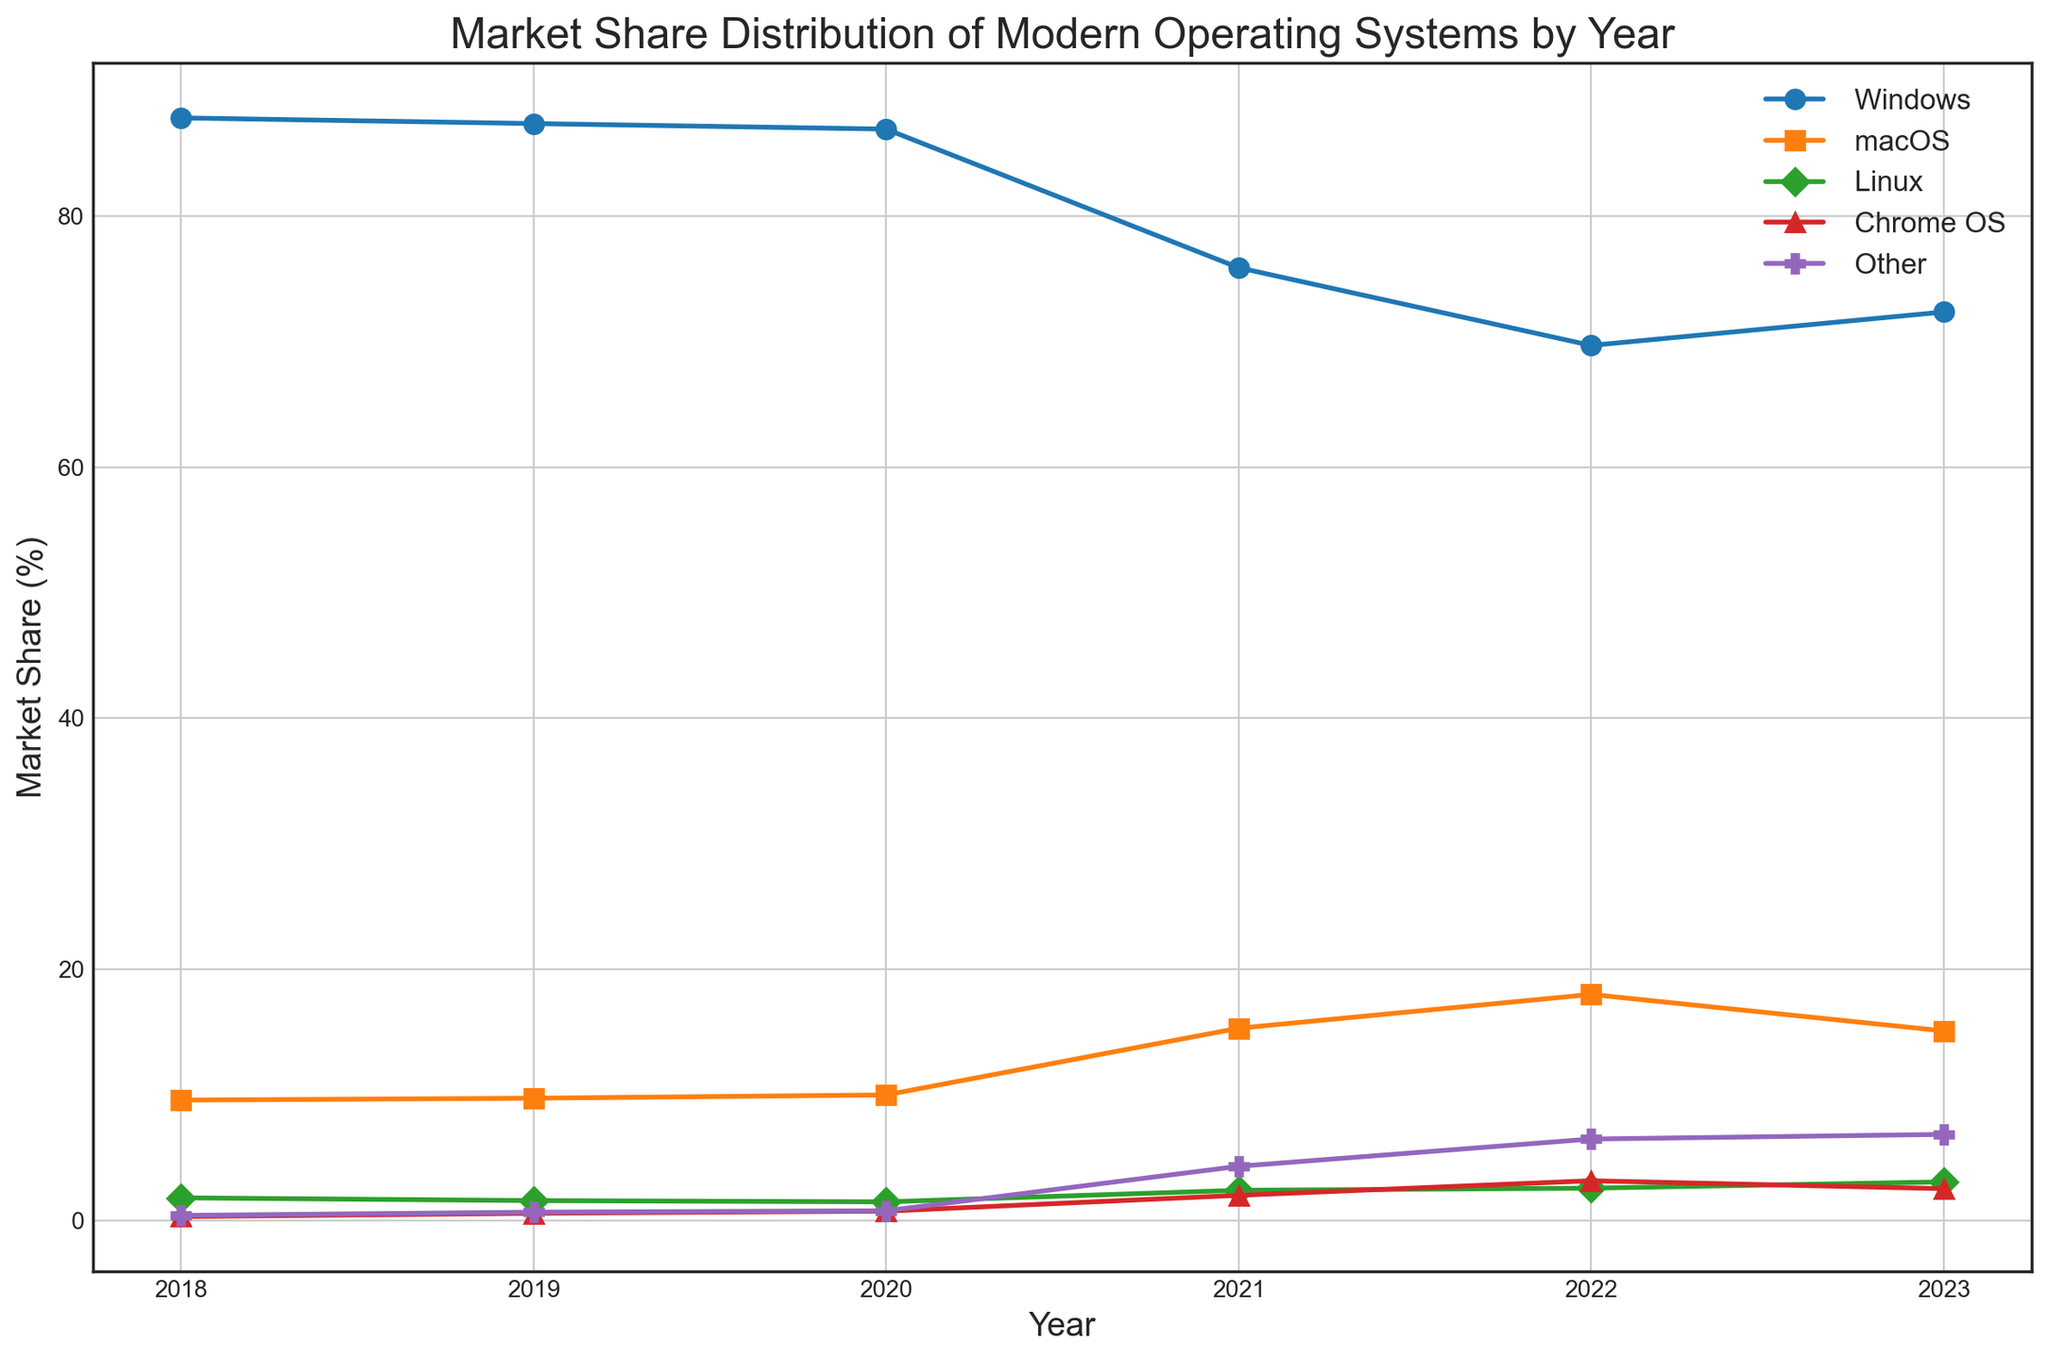What is the trend of the market share of Windows from 2018 to 2023? To find the trend, look at the values of Windows from 2018 to 2023: 87.79, 87.34, 86.9, 75.87, 69.68, 72.34. Notice that there is a general decrease from 2018 to 2022, but a slight increase in 2023.
Answer: Generally decreasing with a slight rise in 2023 Which year has the highest market share for macOS? To determine this, compare the market share values of macOS for each year. The values are 9.61, 9.76, 10.02, 15.33, 18.02, and 15.12. The highest value is 18.02 in 2022.
Answer: 2022 How much did the market share for Chrome OS increase from 2018 to 2021? Calculate the difference between the market shares in those years. For Chrome OS, it was 0.34 in 2018 and 2.03 in 2021. The increase is 2.03 - 0.34.
Answer: 1.69 In which year did 'Other' category see the largest increase in market share compared to the previous year? Evaluate the difference year-over-year for the 'Other' category: 
2019: 0.69 - 0.43 = 0.26,
2020: 0.8 - 0.69 = 0.11,
2021: 4.34 - 0.8 = 3.54,
2022: 6.51 - 4.34 = 2.17,
2023: 6.88 - 6.51 = 0.37. 
The largest increase is from 2020 to 2021.
Answer: 2021 What is the total market share for all operating systems in the year 2020? Add up the values for each operating system in 2020: 86.9 (Windows) + 10.02 (macOS) + 1.51 (Linux) + 0.77 (Chrome OS) + 0.8 (Other) = 100.
Answer: 100 Which two years have the widest spread in the market share of Windows? Calculate the absolute differences between each pair of consecutive years for Windows: 
2018-2019: 87.79 - 87.34 = 0.45,
2019-2020: 87.34 - 86.9 = 0.44,
2020-2021: 86.9 - 75.87 = 11.03,
2021-2022: 75.87 - 69.68 = 6.19,
2022-2023: 69.68 - 72.34 = -2.66 (not relevant for spread). 
The largest spread is from 2020 to 2021 (11.03).
Answer: 2020 to 2021 Which operating system experienced a consistent increase in market share each year from 2018 to 2023? By examining each operating system's values over the years, we see that 'Linux' has increasing values: 1.83, 1.61, 1.51, 2.43, 2.60, 3.10. Despite minor decreases between certain years, overall, it shows a consistent increase.
Answer: Linux What was the average market share of Chrome OS across the years? Sum the market share of Chrome OS across all years and divide by the number of years: 
(0.34 + 0.60 + 0.77 + 2.03 + 3.19 + 2.56) / 6 = 1.25
Answer: 1.25 